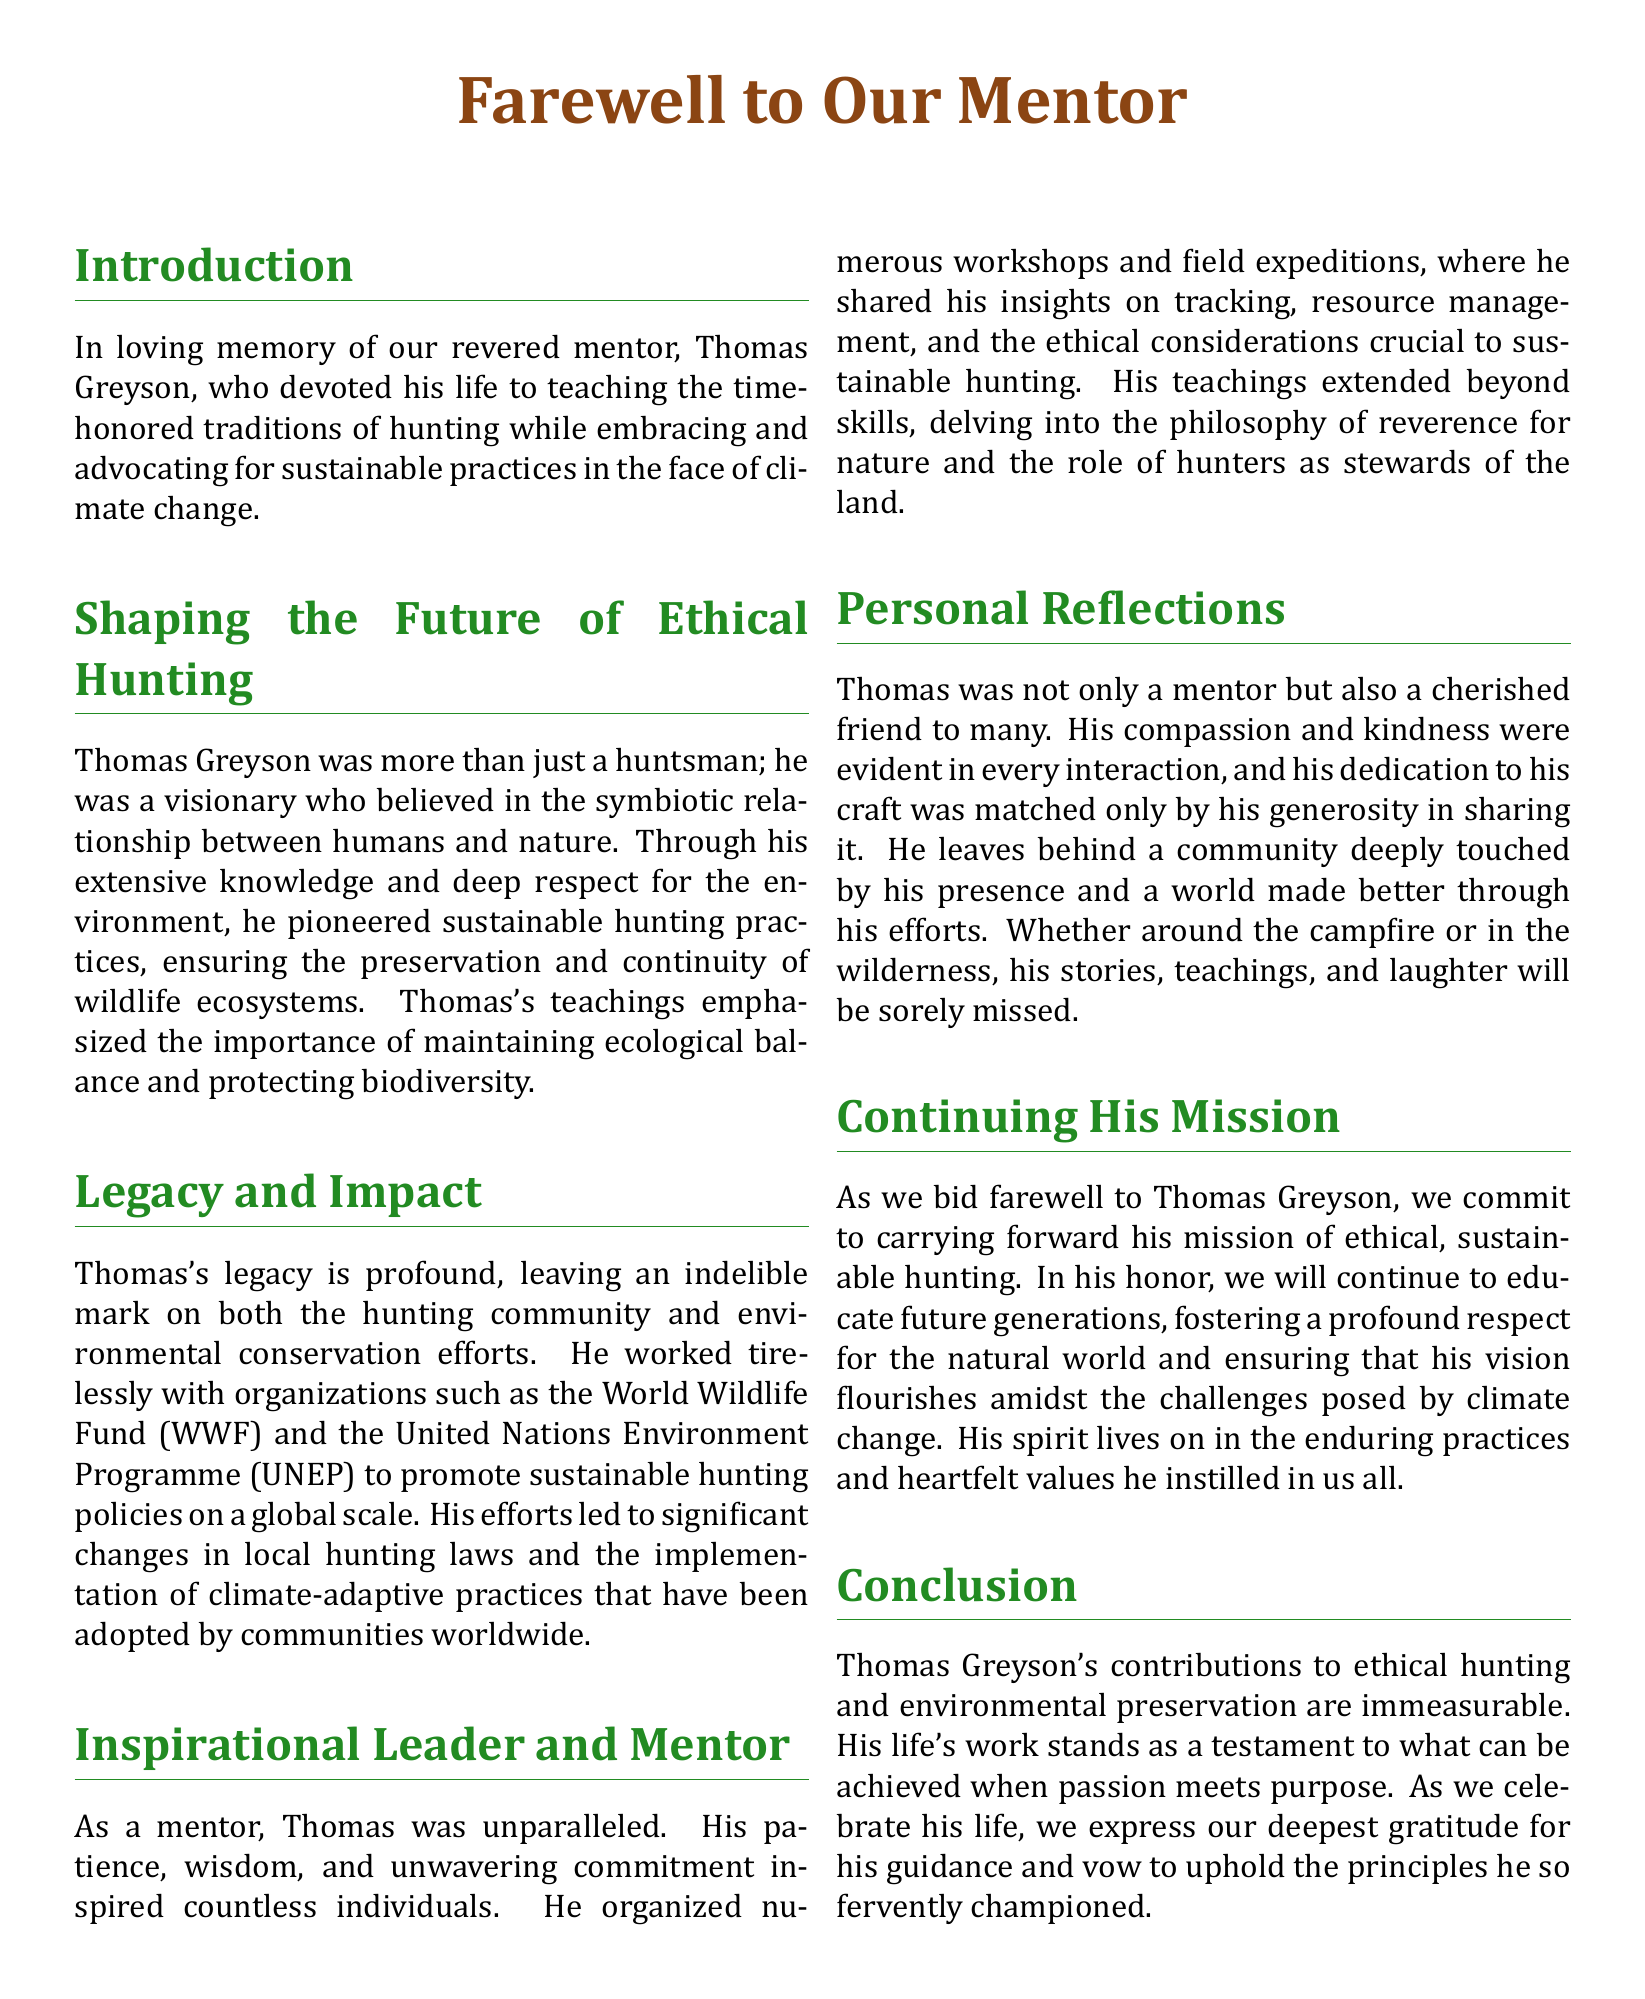What is the name of the mentor being honored? The document honors Thomas Greyson as the mentor who shaped the future of ethical hunting.
Answer: Thomas Greyson What organizations did Thomas Greyson work with? The document mentions that he collaborated with the World Wildlife Fund (WWF) and the United Nations Environment Programme (UNEP).
Answer: WWF and UNEP What is emphasized as important in Thomas's teachings? The teachings highlighted in the document stress the importance of maintaining ecological balance and protecting biodiversity.
Answer: Ecological balance and protecting biodiversity What is one of Thomas's significant impacts on hunting laws? The document states that his efforts led to significant changes in local hunting laws and the implementation of climate-adaptive practices.
Answer: Changes in local hunting laws What type of leader was Thomas described as? The obituary describes Thomas as an unparalleled mentor due to his patience and wisdom.
Answer: Inspirational leader and mentor How did Thomas Greyson contribute to the community? The document mentions his countless workshops and field expeditions that educated individuals on tracking and resource management.
Answer: Organized workshops and field expeditions What commitment is made in honor of Thomas after his passing? The document states a commitment to continue educating future generations about ethical, sustainable hunting.
Answer: Continue educating future generations In what manner is the legacy of Thomas Greyson described? The document describes his legacy as profound, leaving an indelible mark on the hunting community and conservation efforts.
Answer: Profound legacy What is the overall theme of the obituary? The central theme of the obituary revolves around honoring Thomas's contributions to ethical hunting and environmental preservation.
Answer: Ethical hunting and environmental preservation 